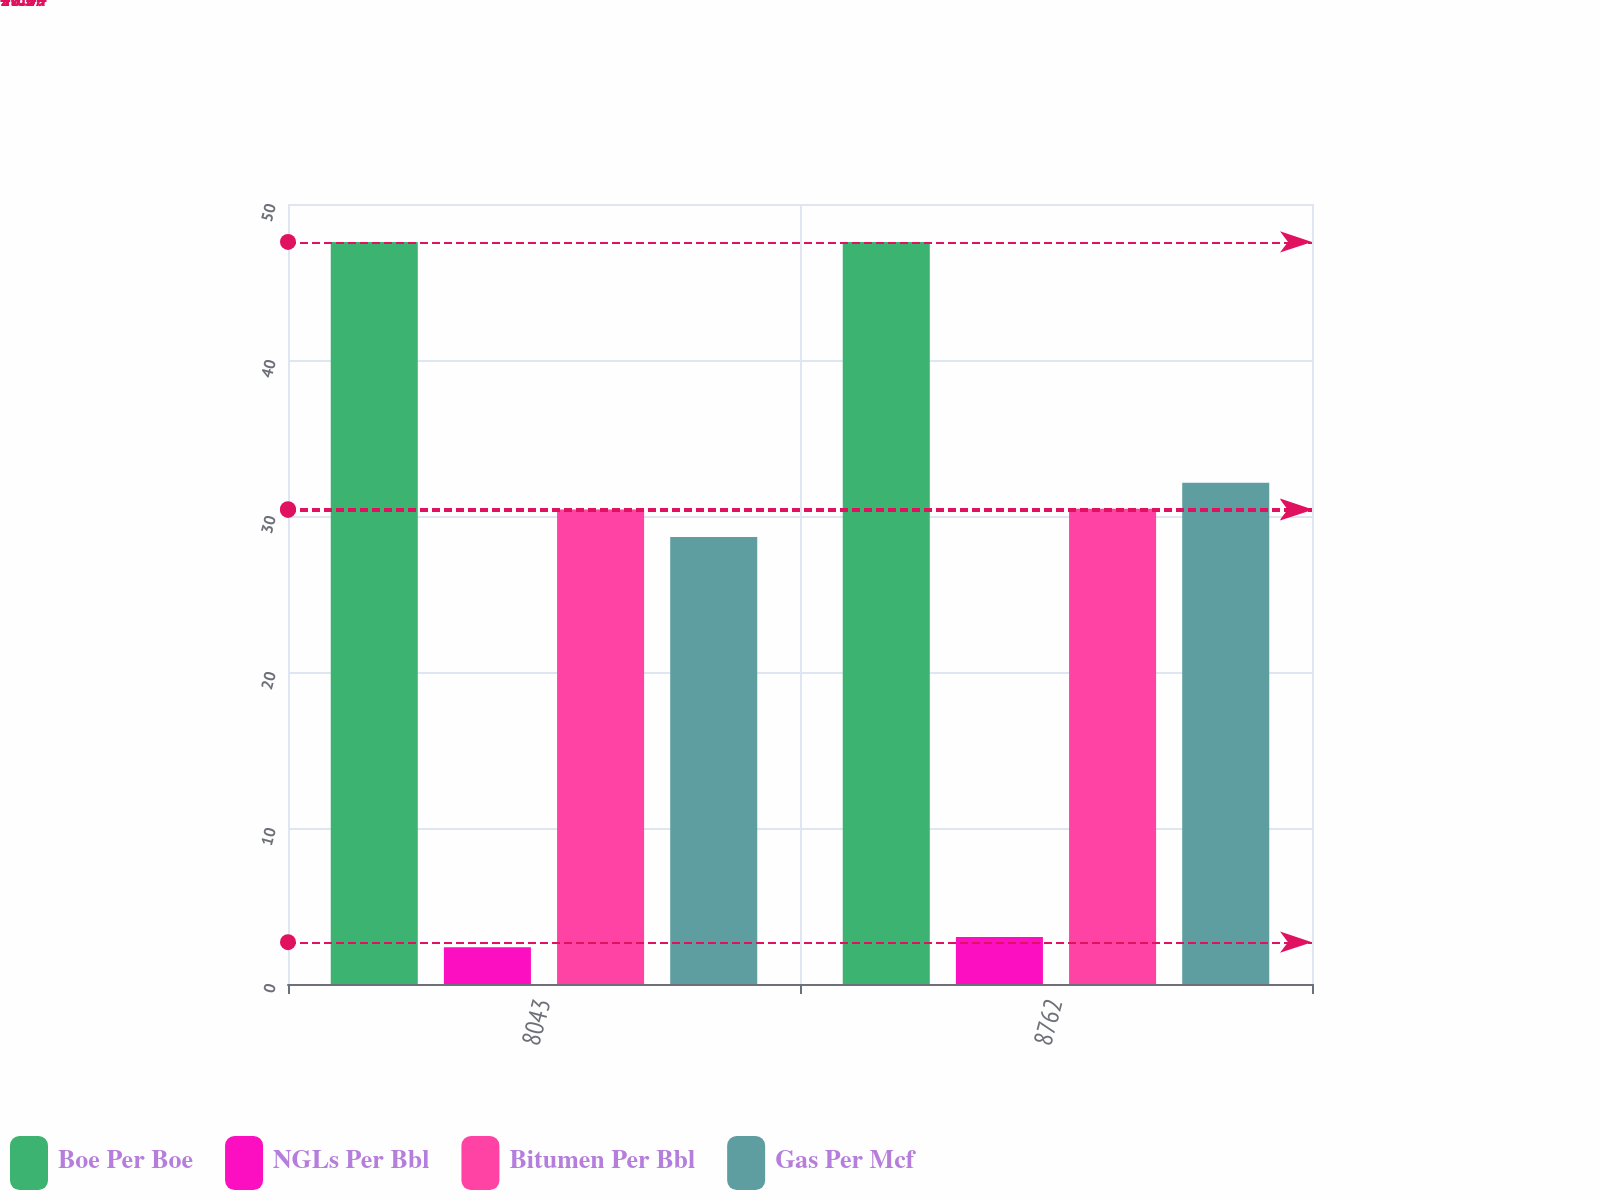<chart> <loc_0><loc_0><loc_500><loc_500><stacked_bar_chart><ecel><fcel>8043<fcel>8762<nl><fcel>Boe Per Boe<fcel>47.57<fcel>47.57<nl><fcel>NGLs Per Bbl<fcel>2.36<fcel>3.01<nl><fcel>Bitumen Per Bbl<fcel>30.42<fcel>30.46<nl><fcel>Gas Per Mcf<fcel>28.65<fcel>32.13<nl></chart> 